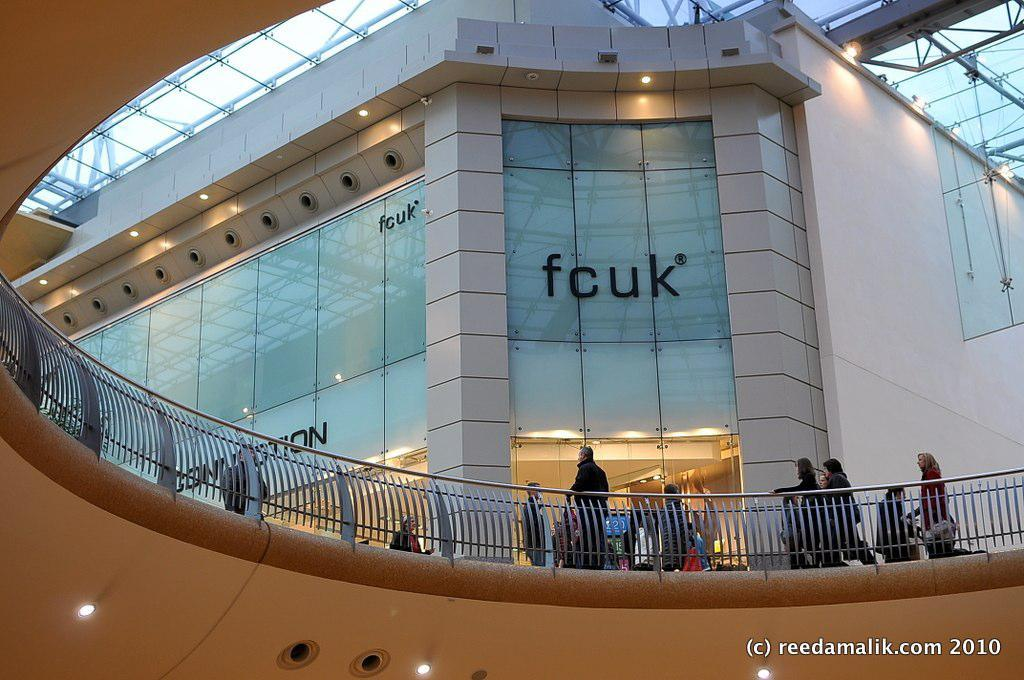How many people are in the group visible in the image? There is a group of people in the image, but the exact number is not specified. What is the surface the people are standing on? The people are standing on the floor. What can be seen behind the group of people? There is a building in front of the people. What type of illumination is present in the image? Lights are present in the image. Is there any additional information or marking on the image? Yes, there is a watermark on the image. How many ants can be seen crawling on the people in the image? There are no ants visible in the image; it only shows a group of people standing on the floor with a building in the background. 